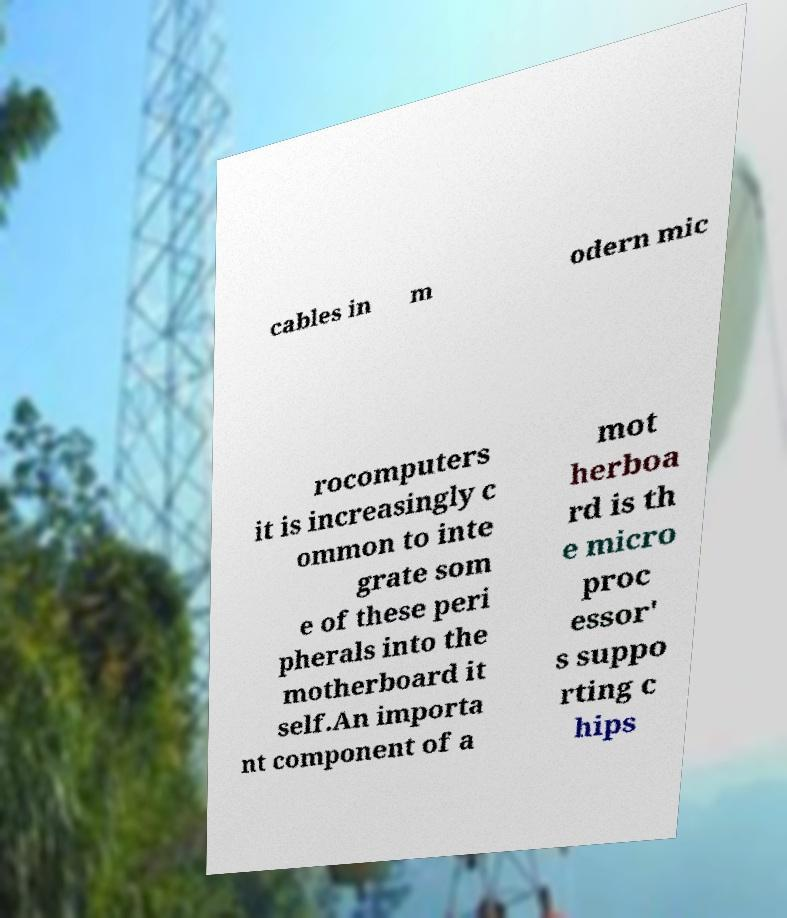Could you assist in decoding the text presented in this image and type it out clearly? cables in m odern mic rocomputers it is increasingly c ommon to inte grate som e of these peri pherals into the motherboard it self.An importa nt component of a mot herboa rd is th e micro proc essor' s suppo rting c hips 